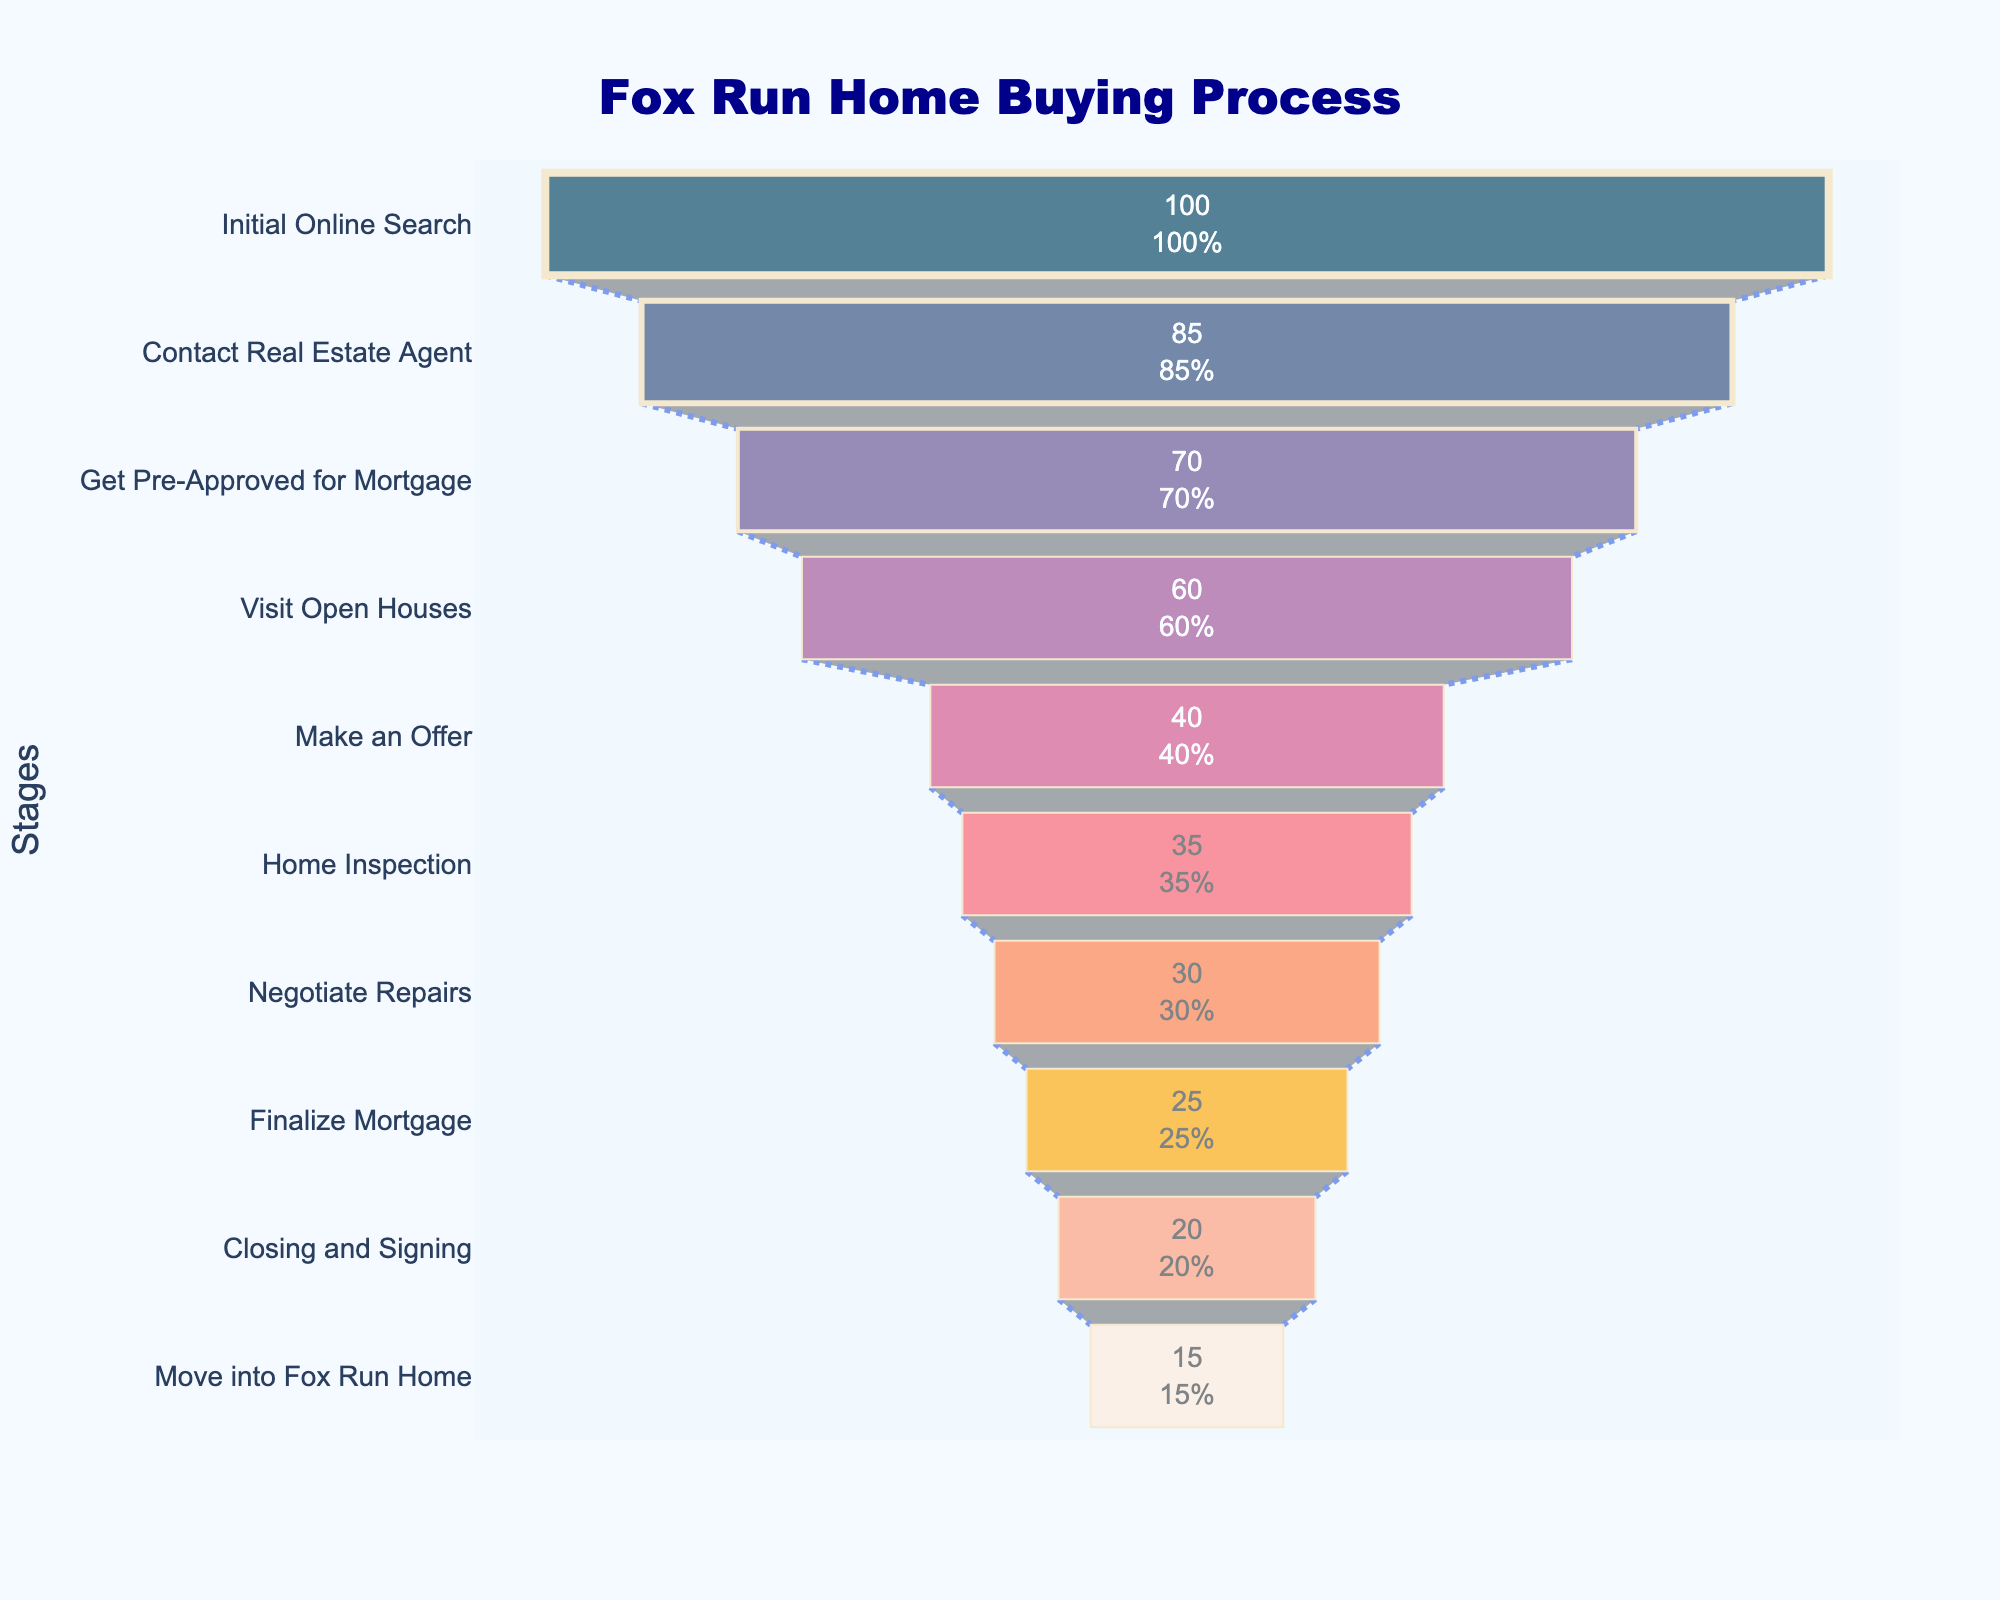What is the title of the chart? The title of the chart is usually prominently displayed at the top and is intended to summarize what the chart is about. In this case, it is "Fox Run Home Buying Process."
Answer: Fox Run Home Buying Process How many stages are shown in the home buying process? Count the number of data points or segments along the y-axis, which represent the stages of the process. In this figure, there are 10 stages listed.
Answer: 10 What percentage of buyers visit open houses? Find the stage labeled "Visit Open Houses" and look at the corresponding percentage shown inside the funnel.
Answer: 60% By what percentage does the number of buyers decrease from making an offer to finalizing the mortgage? Subtract the percentage of buyers who finalize the mortgage (25%) from those who make an offer (40%). The difference is 40% - 25% = 15%.
Answer: 15% Which stage has the steepest drop in percentage of buyers? Compare the percentages between consecutive stages to find the biggest difference. The steepest drop is from "Visit Open Houses" at 60% to "Make an Offer" at 40%, a 20% drop.
Answer: Make an Offer What is the difference in percentage of buyers between the initial online search and moving into the Fox Run home? Subtract the percentage of the final stage (15%) from the initial stage (100%). The difference is 100% - 15% = 85%.
Answer: 85% What is the median percentage of buyers across all stages? List all percentages in ascending order: 15, 20, 25, 30, 35, 40, 60, 70, 85, 100. The median is the average of the 5th and 6th numbers in the list: (35 + 40) / 2 = 37.5%.
Answer: 37.5% How many stages have a percentage of buyers greater than 50%? Identify the stages where the percentage is greater than 50%: "Initial Online Search," "Contact Real Estate Agent," "Get Pre-Approved for Mortgage," and "Visit Open Houses." There are 4 such stages.
Answer: 4 What percentage of buyers negotiate repairs? Look for the stage labeled "Negotiate Repairs" and read off the corresponding percentage.
Answer: 30% Which stage has the smallest percentage of buyers, and what is it? Identify the stage with the smallest percentage at the bottom of the funnel, which is "Move into Fox Run Home" with 15%.
Answer: Move into Fox Run Home; 15% 